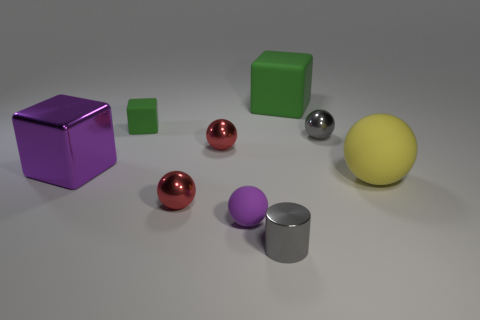Are there any tiny metal cylinders on the right side of the purple block?
Keep it short and to the point. Yes. There is a green rubber thing right of the red thing behind the big metallic thing; what is its shape?
Offer a terse response. Cube. Is the number of small cylinders that are behind the tiny matte cube less than the number of small gray metallic things in front of the purple shiny cube?
Your answer should be very brief. Yes. There is another rubber object that is the same shape as the small green object; what is its color?
Your answer should be very brief. Green. How many green rubber objects are on the right side of the purple matte ball and in front of the large green thing?
Ensure brevity in your answer.  0. Is the number of big blocks right of the purple shiny object greater than the number of tiny shiny cylinders to the left of the small purple sphere?
Keep it short and to the point. Yes. The purple metallic cube is what size?
Provide a short and direct response. Large. Is there a small object that has the same shape as the large purple thing?
Offer a very short reply. Yes. Is the shape of the big green matte thing the same as the large thing that is to the left of the large matte cube?
Provide a succinct answer. Yes. How big is the matte thing that is behind the purple matte sphere and in front of the big purple block?
Your response must be concise. Large. 